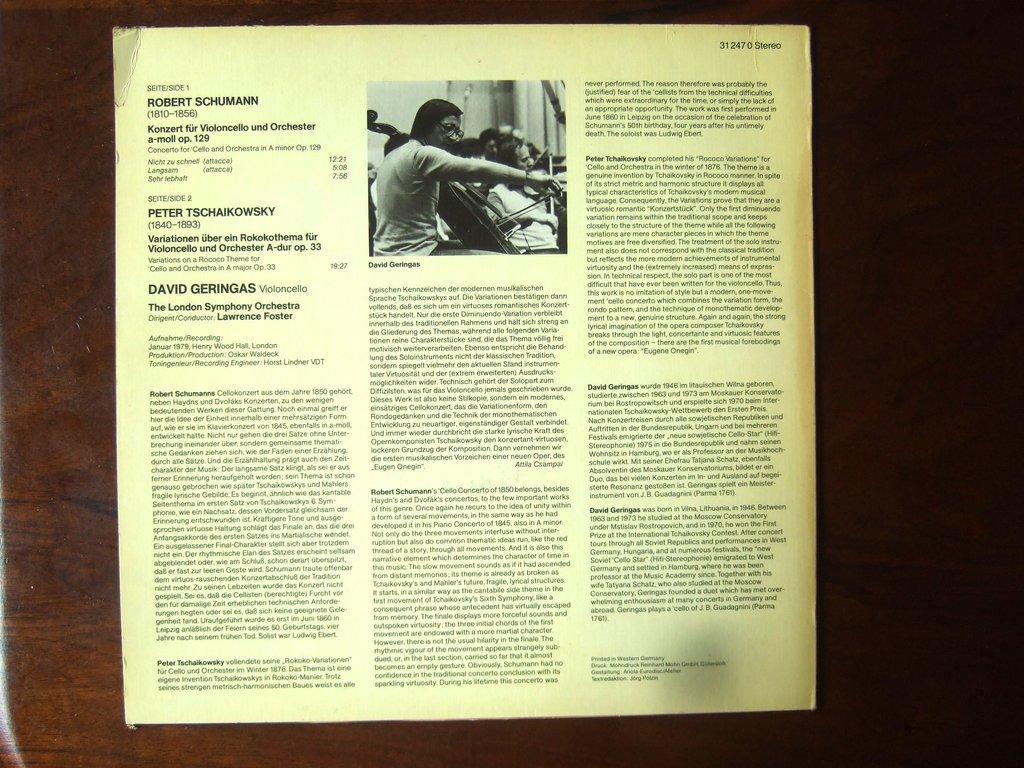Describe this image in one or two sentences. In this image there is a paper with paragraphs and a photo, stick to the wooden board. 